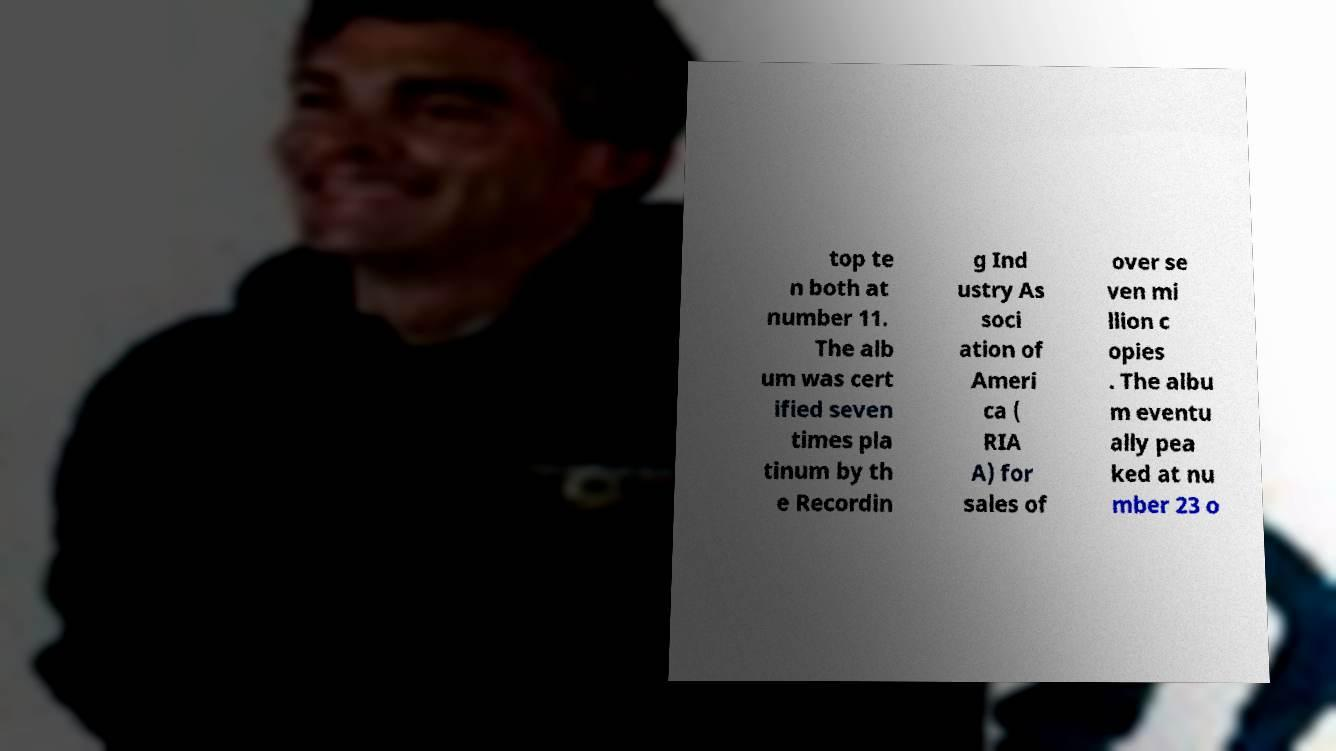Could you extract and type out the text from this image? top te n both at number 11. The alb um was cert ified seven times pla tinum by th e Recordin g Ind ustry As soci ation of Ameri ca ( RIA A) for sales of over se ven mi llion c opies . The albu m eventu ally pea ked at nu mber 23 o 